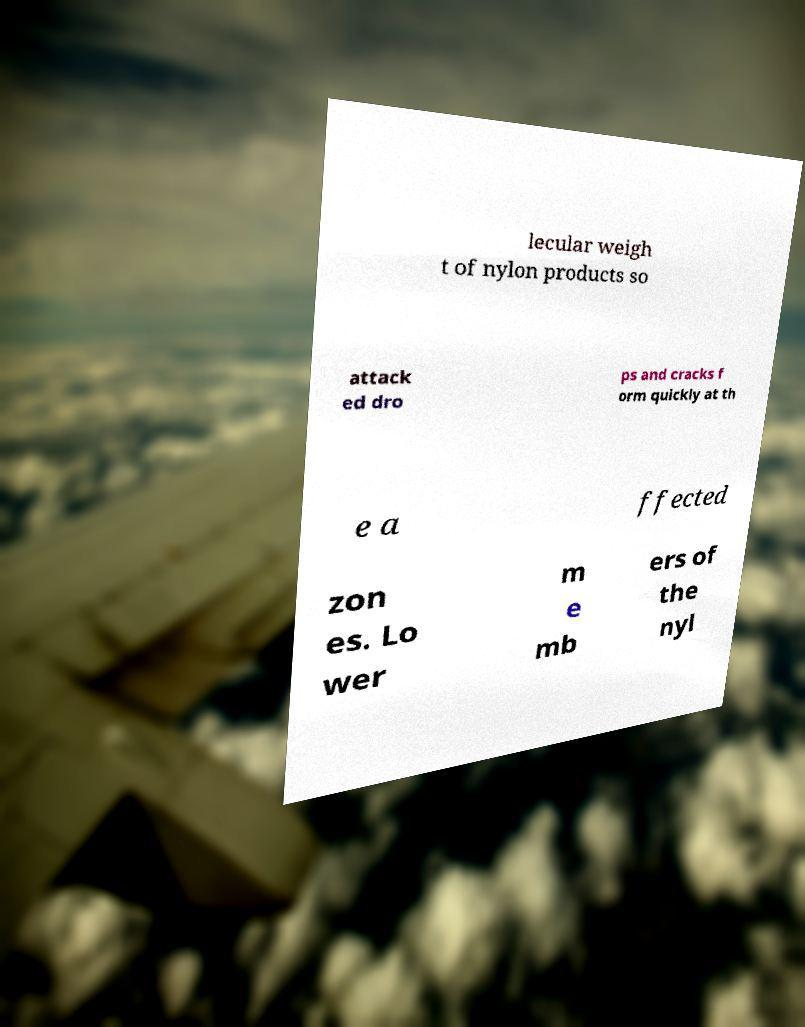There's text embedded in this image that I need extracted. Can you transcribe it verbatim? lecular weigh t of nylon products so attack ed dro ps and cracks f orm quickly at th e a ffected zon es. Lo wer m e mb ers of the nyl 